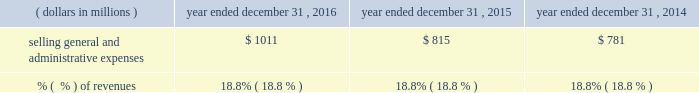2015 compared to 2014 when compared to 2014 , costs of revenue in 2015 increased $ 41 million .
This increase included a constant currency increase in expenses of approximately $ 238 million , or 8.9% ( 8.9 % ) , partially offset by a positive impact of approximately $ 197 million from the effects of foreign currency fluctuations .
The constant currency growth was comprised of a $ 71 million increase in commercial solutions , which included the impact from the encore acquisition which closed in july 2014 , a $ 146 million increase in research & development solutions , which included the incremental impact from the businesses that quest contributed to q2 solutions , and a $ 21 million increase in integrated engagement services .
The decrease in costs of revenue as a percent of revenues for 2015 was primarily as a result of an improvement in constant currency profit margin in the commercial solutions , research & development solutions and integrated engagement services segments ( as more fully described in the segment discussion later in this section ) .
For 2015 , this constant currency profit margin expansion was partially offset by the effect from a higher proportion of consolidated revenues being contributed by our lower margin integrated engagement services segment when compared to 2014 as well as a negative impact from foreign currency fluctuations .
Selling , general and administrative expenses , exclusive of depreciation and amortization .
2016 compared to 2015 the $ 196 million increase in selling , general and administrative expenses in 2016 included a constant currency increase of $ 215 million , or 26.4% ( 26.4 % ) , partially offset by a positive impact of approximately $ 19 million from the effects of foreign currency fluctuations .
The constant currency growth was comprised of a $ 151 million increase in commercial solutions , which includes $ 158 million from the merger with ims health , partially offset by a decline in the legacy service offerings , a $ 32 million increase in research & development solutions , which includes the incremental impact from the businesses that quest contributed to q2 solutions , a $ 3 million increase in integrated engagement services , and a $ 29 million increase in general corporate and unallocated expenses , which includes $ 37 million from the merger with ims health .
The constant currency increase in general corporate and unallocated expenses in 2016 was primarily due to higher stock-based compensation expense .
2015 compared to 2014 the $ 34 million increase in selling , general and administrative expenses in 2015 included a constant currency increase of $ 74 million , or 9.5% ( 9.5 % ) , partially offset by a positive impact of approximately $ 42 million from the effects of foreign currency fluctuations .
The constant currency growth was comprised of a $ 14 million increase in commercial solutions , which included the impact from the encore acquisition which closed in july 2014 , a $ 40 million increase in research & development solutions , which included the incremental impact from the businesses that quest contributed to q2 solutions , a $ 4 million increase in integrated engagement services , and a $ 14 million increase in general corporate and unallocated expenses .
The constant currency increase in general corporate and unallocated expenses in 2015 was primarily due to higher stock-based compensation expense and costs associated with the q2 solutions transaction. .
What is the percent increase in selling and administrative expenses from 2015 to 2016? 
Computations: ((1011 - 815) / 815)
Answer: 0.24049. 